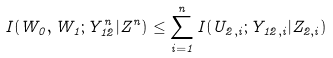<formula> <loc_0><loc_0><loc_500><loc_500>I ( W _ { 0 } , W _ { 1 } ; Y _ { 1 2 } ^ { n } | Z ^ { n } ) \leq \sum _ { i = 1 } ^ { n } I ( U _ { 2 , i } ; Y _ { 1 2 , i } | Z _ { 2 , i } )</formula> 